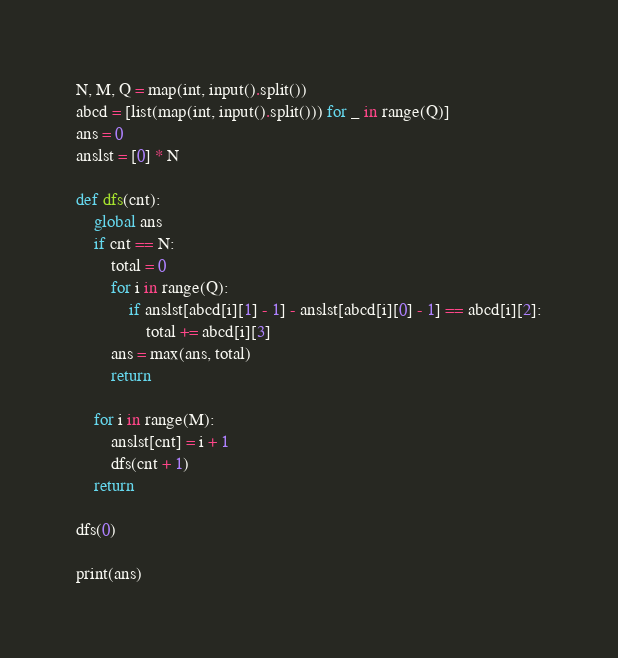<code> <loc_0><loc_0><loc_500><loc_500><_Python_>N, M, Q = map(int, input().split())
abcd = [list(map(int, input().split())) for _ in range(Q)]
ans = 0
anslst = [0] * N

def dfs(cnt):
    global ans
    if cnt == N:
        total = 0
        for i in range(Q):
            if anslst[abcd[i][1] - 1] - anslst[abcd[i][0] - 1] == abcd[i][2]:
                total += abcd[i][3]
        ans = max(ans, total)
        return

    for i in range(M):
        anslst[cnt] = i + 1
        dfs(cnt + 1)
    return

dfs(0)

print(ans)</code> 